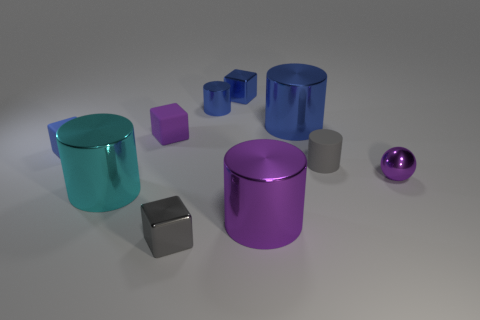Are there fewer tiny things in front of the gray cylinder than small purple metallic spheres?
Offer a very short reply. No. What number of big objects are either gray metal cubes or blue cubes?
Your answer should be compact. 0. The blue matte thing has what size?
Keep it short and to the point. Small. Are there any other things that have the same material as the gray cube?
Your response must be concise. Yes. There is a large blue cylinder; what number of small objects are on the right side of it?
Provide a short and direct response. 2. The purple object that is the same shape as the gray rubber thing is what size?
Provide a short and direct response. Large. How big is the cylinder that is both left of the large blue metallic cylinder and behind the sphere?
Your answer should be compact. Small. Is the color of the shiny ball the same as the shiny block in front of the gray cylinder?
Provide a succinct answer. No. How many blue objects are either rubber objects or metallic objects?
Your answer should be very brief. 4. The tiny purple matte thing has what shape?
Provide a short and direct response. Cube. 